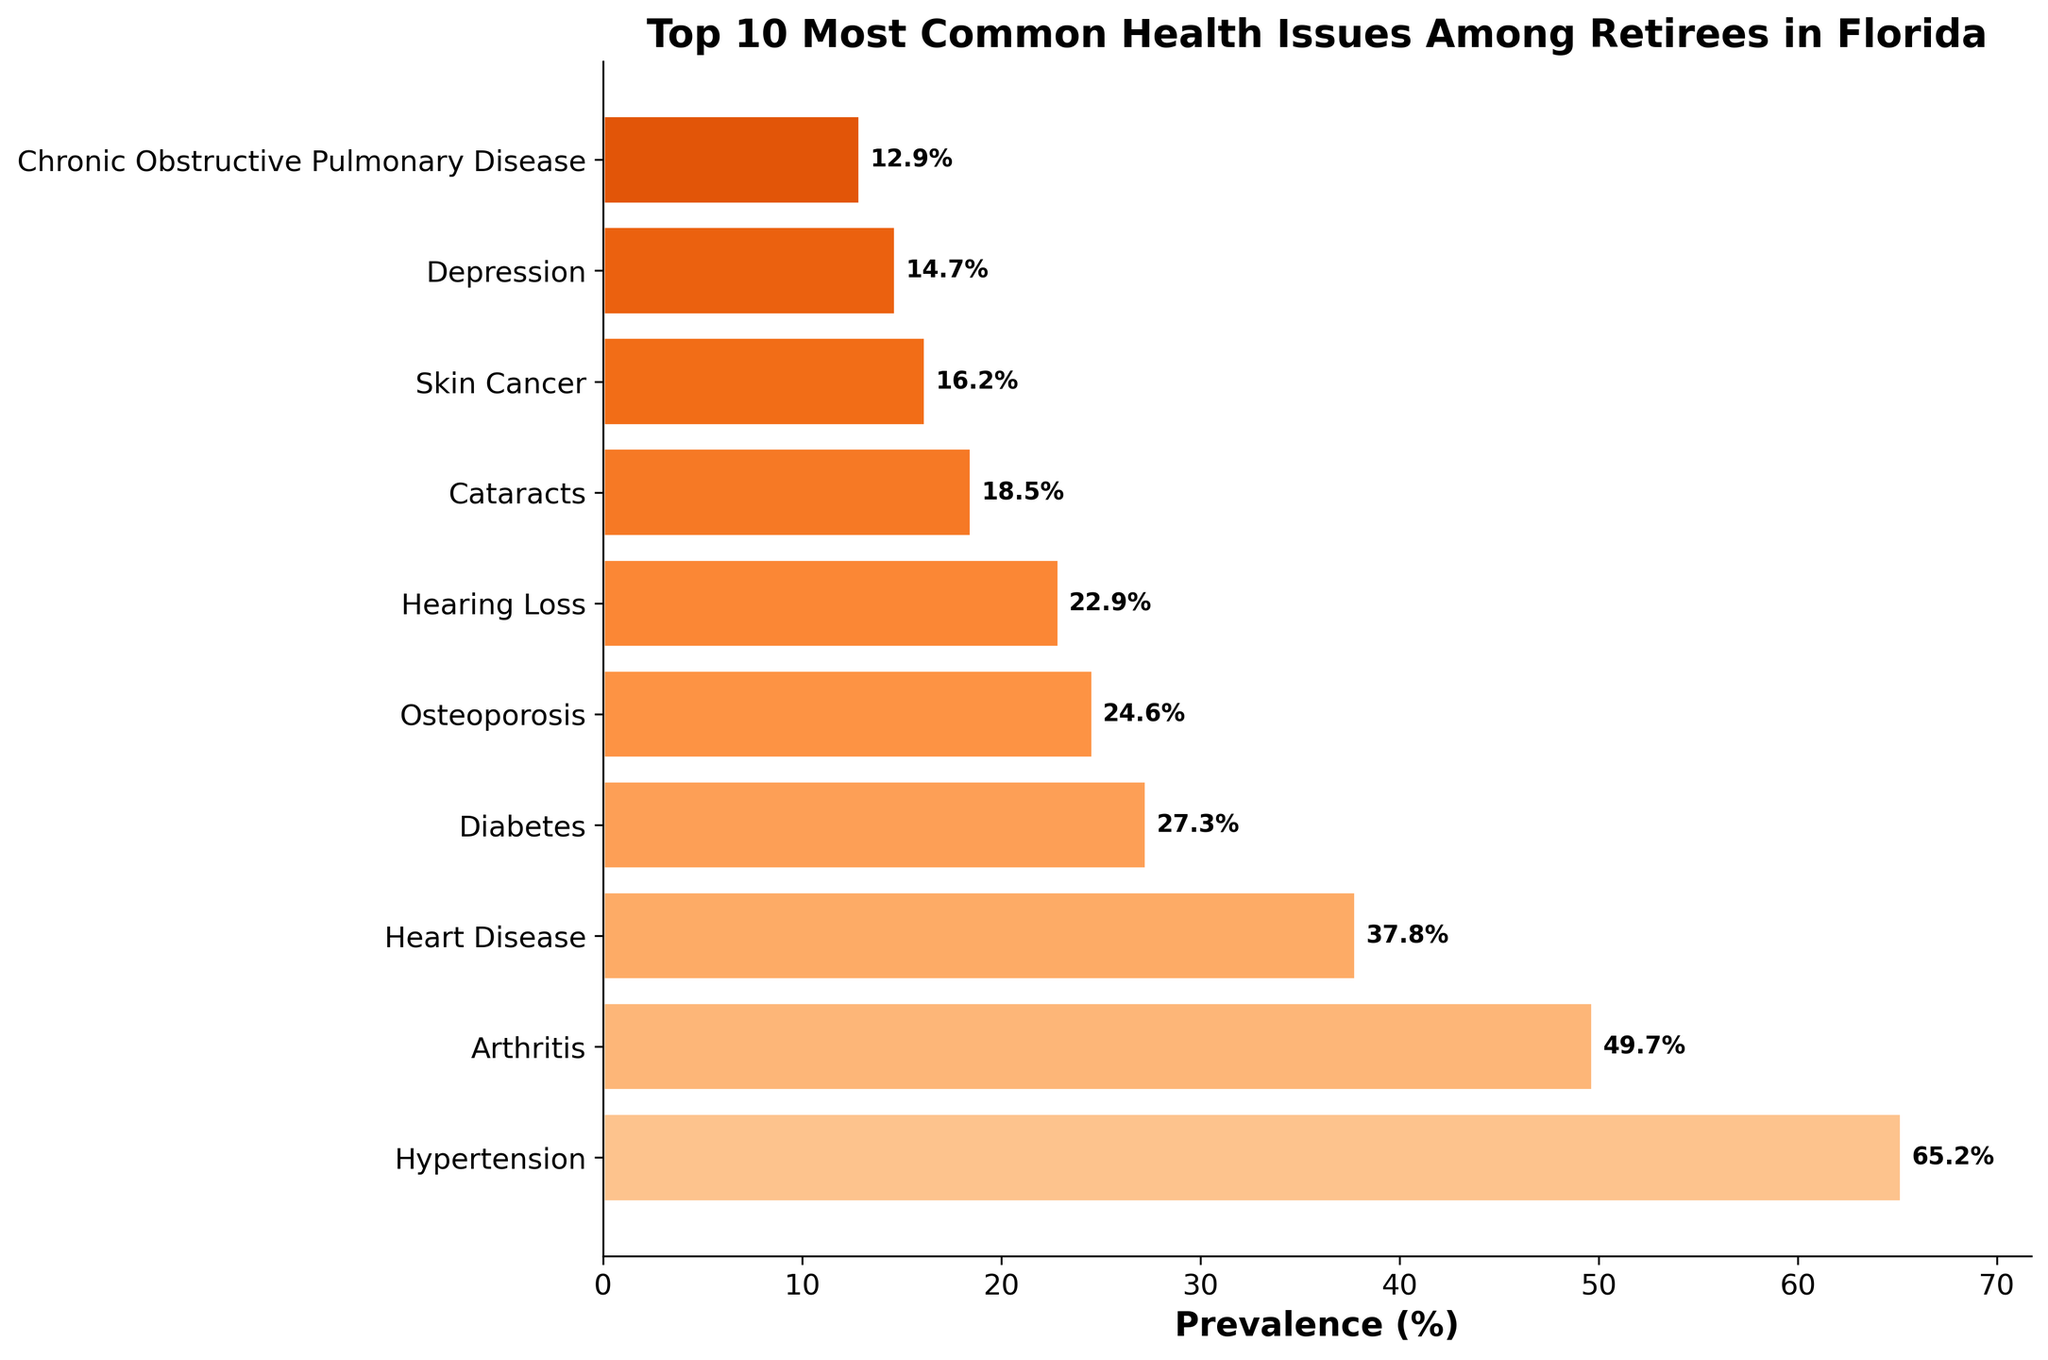What is the most common health issue among retirees in Florida? The bar chart shows that the health issue with the highest prevalence is at the top of the chart. This issue is Hypertension with a prevalence of 65.2%.
Answer: Hypertension Which health issue has the second highest prevalence among retirees? The second bar from the top represents the health issue with the second highest prevalence, which is Arthritis with 49.7%.
Answer: Arthritis What is the total prevalence percentage of Heart Disease and Diabetes combined? The prevalence percentages of Heart Disease and Diabetes are 37.8% and 27.3% respectively. Summing these two values gives 37.8 + 27.3 = 65.1%.
Answer: 65.1% How many health issues have a prevalence greater than 20%? By examining the bar chart, we identify the bars corresponding to issues with a prevalence over 20%. There are six such bars: Hypertension, Arthritis, Heart Disease, Diabetes, Osteoporosis, and Hearing Loss.
Answer: 6 Which health issue has a lower prevalence, Cataracts or Skin Cancer? Comparing the lengths of bars corresponding to Cataracts and Skin Cancer, we see that Cataracts has a longer bar, meaning higher prevalence, so Skin Cancer has a lower prevalence.
Answer: Skin Cancer What is the average prevalence percentage of the top 3 most common health issues? The prevalence percentages of the top 3 health issues are 65.2%, 49.7%, and 37.8%. The average is calculated as (65.2 + 49.7 + 37.8) / 3 = 152.7 / 3 = 50.9%.
Answer: 50.9% What is the difference in prevalence between Osteoporosis and Depression? The prevalence of Osteoporosis is 24.6%, and for Depression it is 14.7%. The difference is 24.6 - 14.7 = 9.9%.
Answer: 9.9% Are there any health issues with a prevalence close to 20%? Examining the chart, we see that Hearing Loss has a prevalence of 22.9%, which is close to 20%.
Answer: Hearing Loss What color is used to represent the bar for Diabetes and how does its length compare to Heart Disease? The bar for Diabetes is represented in an orange hue. Comparing the lengths, the Diabetes bar is shorter, indicating its prevalence of 27.3% is less than Heart Disease at 37.8%.
Answer: Orange, shorter Which health issue is positioned at the bottom of the bar chart and what is its prevalence? The health issue at the bottom of the bar chart is Chronic Obstructive Pulmonary Disease, with a prevalence of 12.9%.
Answer: Chronic Obstructive Pulmonary Disease 